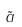Convert formula to latex. <formula><loc_0><loc_0><loc_500><loc_500>\tilde { a }</formula> 